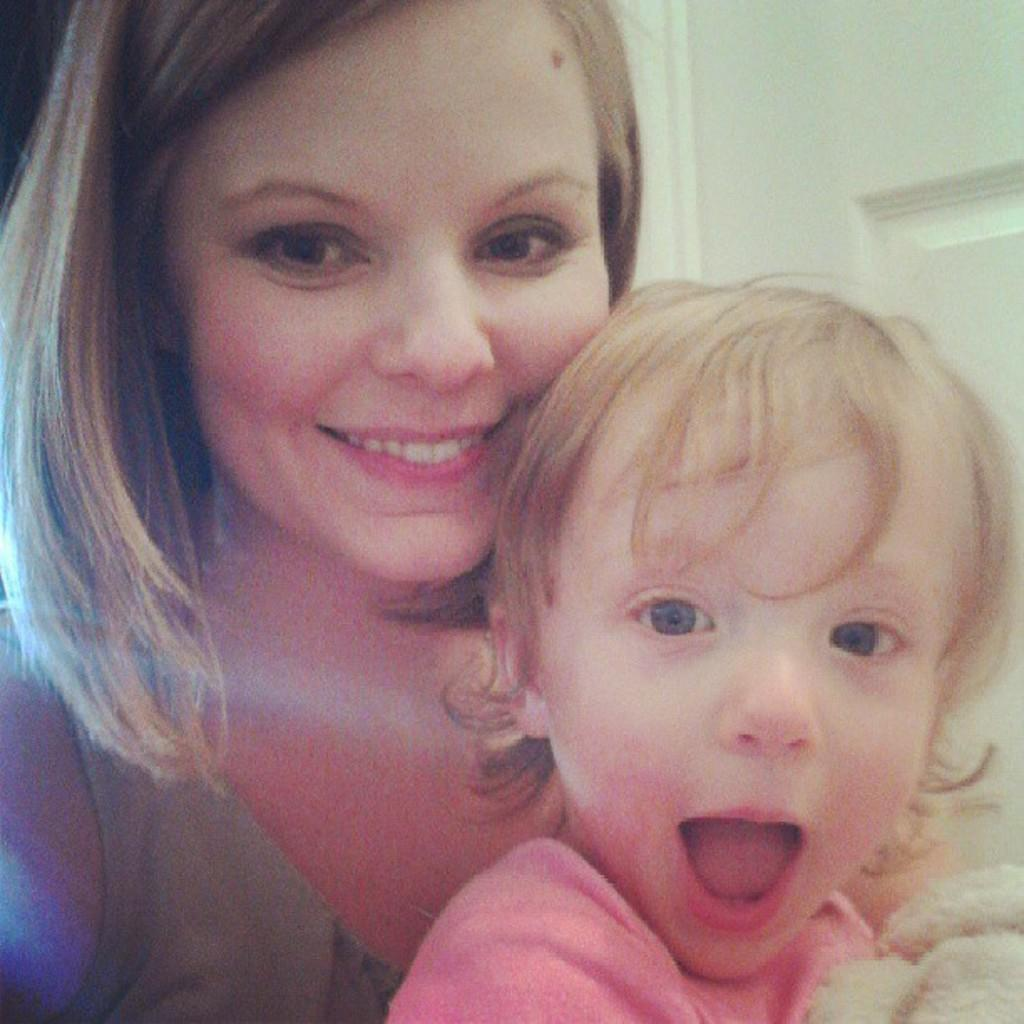Who is the main subject in the center of the image? There is a girl and a lady in the center of the image. Can you describe the relationship between the girl and the lady? The facts provided do not give any information about the relationship between the girl and the lady. What is visible in the background of the image? There is a door in the background of the image. How many mountains can be seen in the image? There are no mountains visible in the image. What type of vase is present in the image? There is no vase present in the image. 